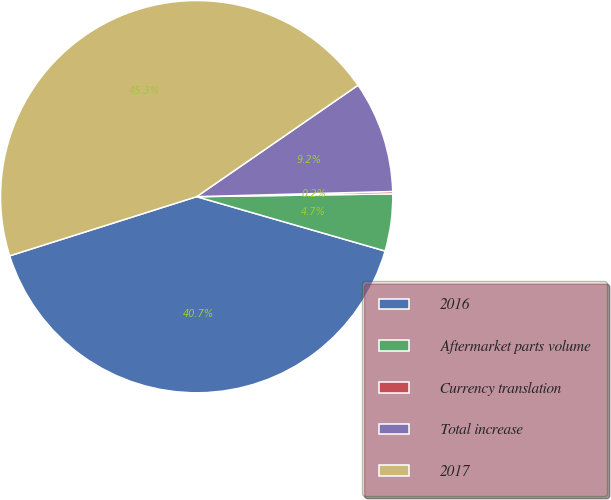Convert chart to OTSL. <chart><loc_0><loc_0><loc_500><loc_500><pie_chart><fcel>2016<fcel>Aftermarket parts volume<fcel>Currency translation<fcel>Total increase<fcel>2017<nl><fcel>40.65%<fcel>4.7%<fcel>0.19%<fcel>9.2%<fcel>45.26%<nl></chart> 